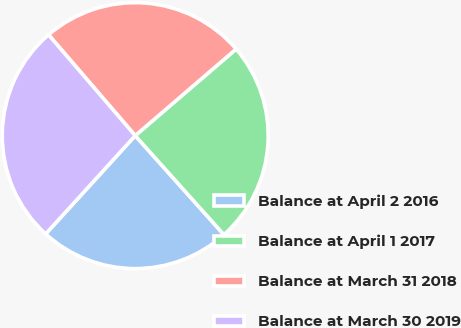Convert chart to OTSL. <chart><loc_0><loc_0><loc_500><loc_500><pie_chart><fcel>Balance at April 2 2016<fcel>Balance at April 1 2017<fcel>Balance at March 31 2018<fcel>Balance at March 30 2019<nl><fcel>23.38%<fcel>24.66%<fcel>25.01%<fcel>26.94%<nl></chart> 